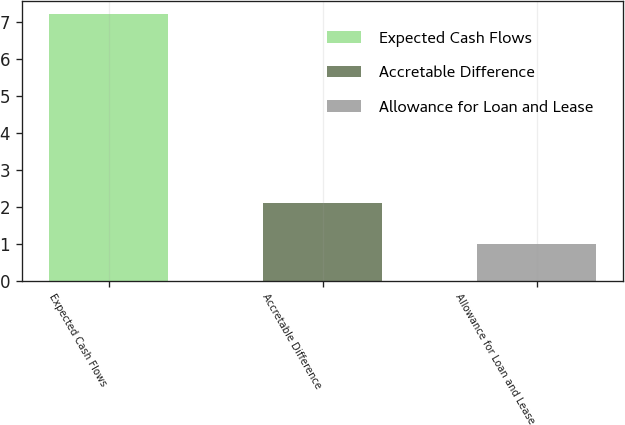Convert chart to OTSL. <chart><loc_0><loc_0><loc_500><loc_500><bar_chart><fcel>Expected Cash Flows<fcel>Accretable Difference<fcel>Allowance for Loan and Lease<nl><fcel>7.2<fcel>2.1<fcel>1<nl></chart> 